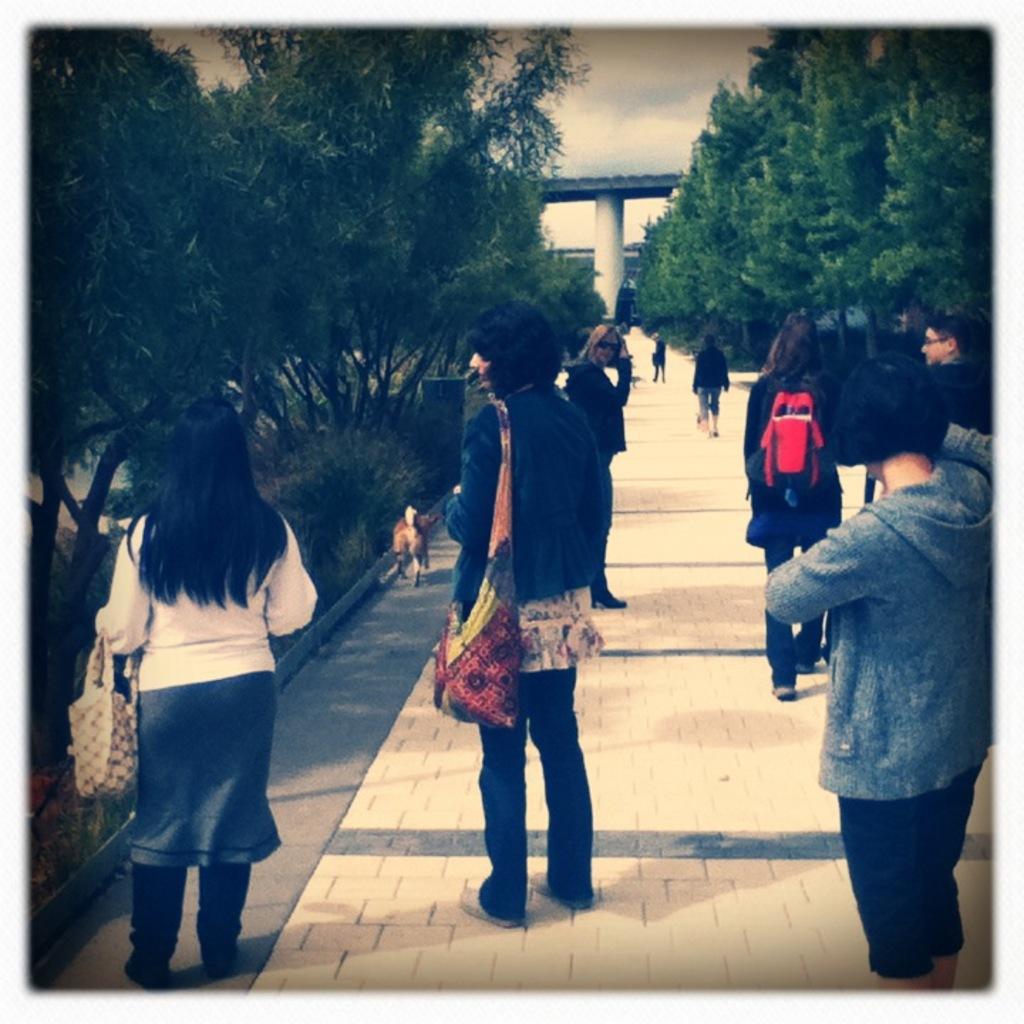Can you describe this image briefly? In this picture we can see a group of people were some are standing and some are walking on a path, bags, dog, pillar, trees, bridge and in the background we can see the sky with clouds. 